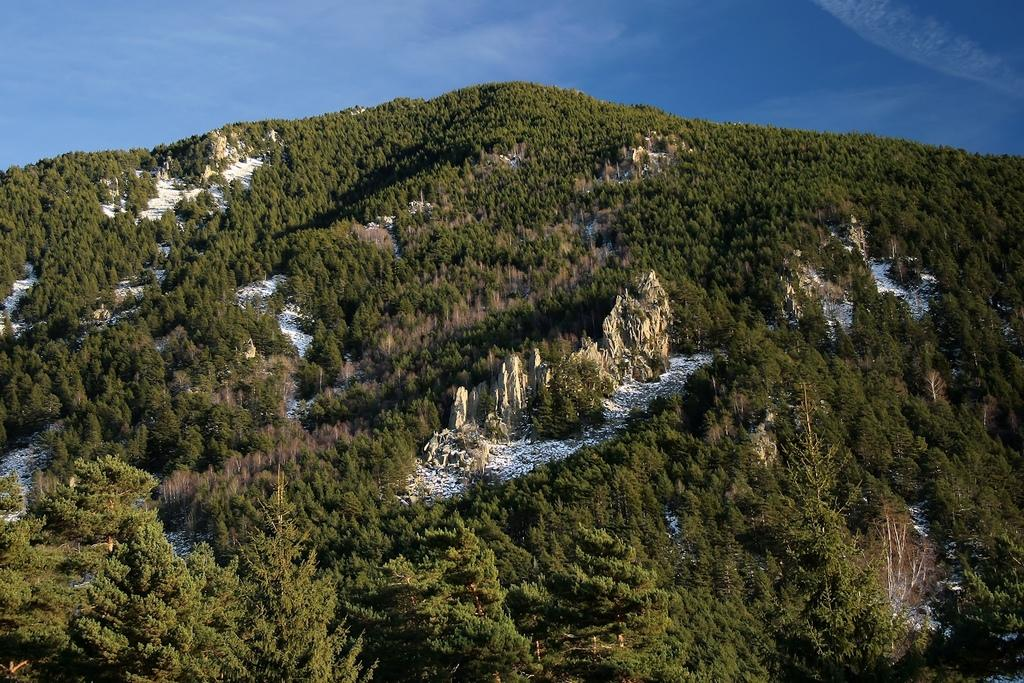What type of vegetation can be seen on the hills in the image? There are trees on the hills in the image. What is the color of the sky in the image? The sky is blue in color. How many beads are hanging from the trees in the image? There are no beads present in the image; it features trees on hills with a blue sky. What type of soda is being served in the image? There is no soda present in the image; it only shows trees on hills and a blue sky. 